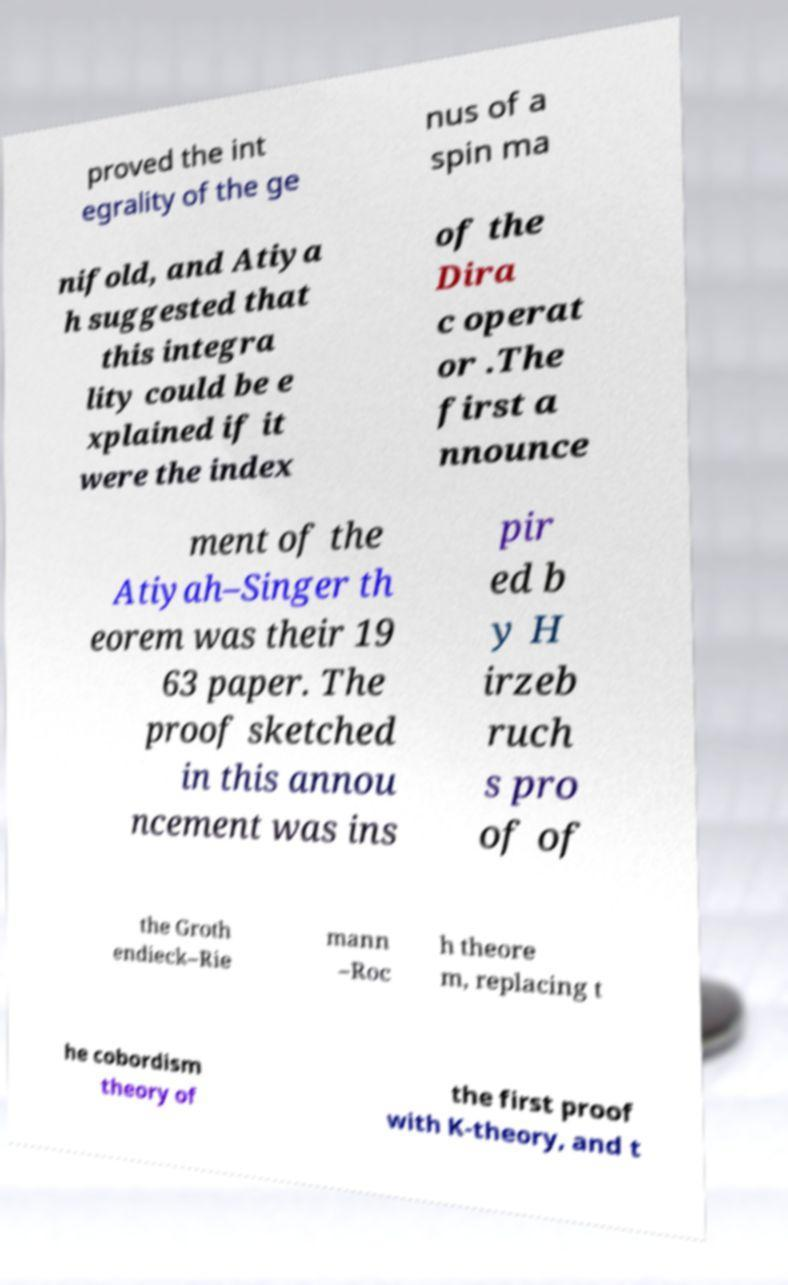Could you extract and type out the text from this image? proved the int egrality of the ge nus of a spin ma nifold, and Atiya h suggested that this integra lity could be e xplained if it were the index of the Dira c operat or .The first a nnounce ment of the Atiyah–Singer th eorem was their 19 63 paper. The proof sketched in this annou ncement was ins pir ed b y H irzeb ruch s pro of of the Groth endieck–Rie mann –Roc h theore m, replacing t he cobordism theory of the first proof with K-theory, and t 